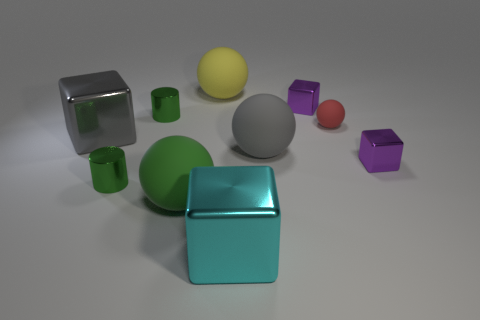Subtract all green cylinders. How many purple cubes are left? 2 Subtract all big gray cubes. How many cubes are left? 3 Subtract 1 spheres. How many spheres are left? 3 Subtract all cyan blocks. How many blocks are left? 3 Subtract all cylinders. How many objects are left? 8 Subtract all blue blocks. Subtract all yellow cylinders. How many blocks are left? 4 Add 6 purple metal objects. How many purple metal objects are left? 8 Add 8 big red rubber objects. How many big red rubber objects exist? 8 Subtract 0 blue blocks. How many objects are left? 10 Subtract all gray shiny objects. Subtract all green matte objects. How many objects are left? 8 